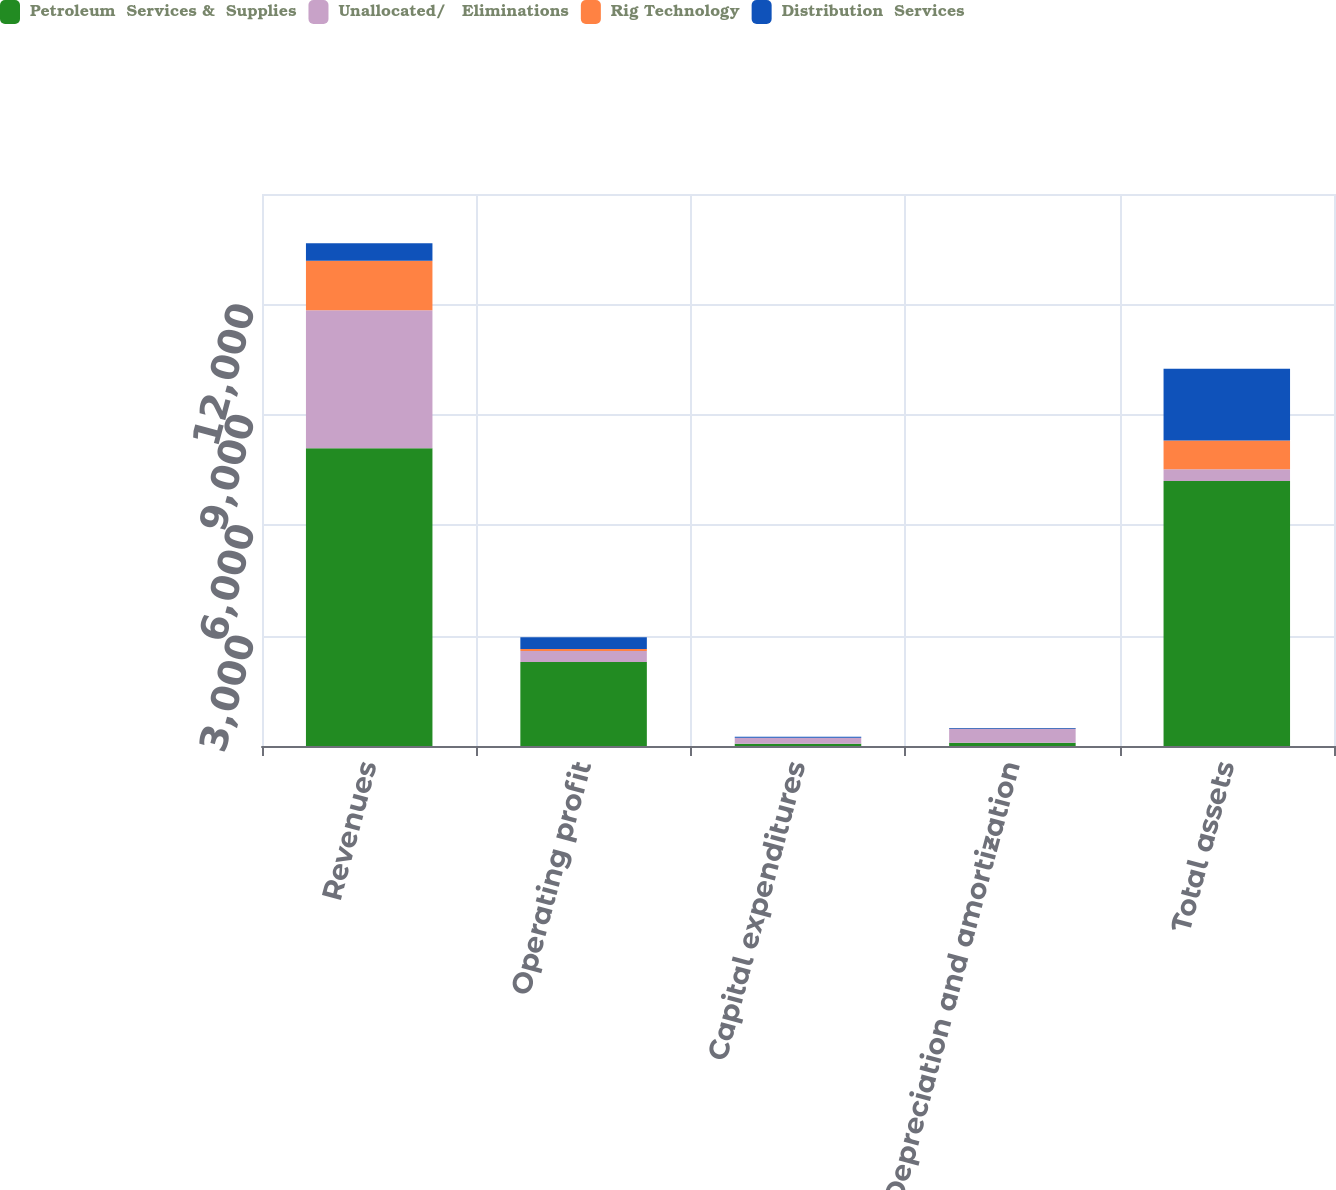<chart> <loc_0><loc_0><loc_500><loc_500><stacked_bar_chart><ecel><fcel>Revenues<fcel>Operating profit<fcel>Capital expenditures<fcel>Depreciation and amortization<fcel>Total assets<nl><fcel>Petroleum  Services &  Supplies<fcel>8093<fcel>2283<fcel>61<fcel>90<fcel>7203<nl><fcel>Unallocated/   Eliminations<fcel>3745<fcel>301<fcel>161<fcel>374<fcel>319<nl><fcel>Rig Technology<fcel>1350<fcel>50<fcel>3<fcel>8<fcel>781<nl><fcel>Distribution  Services<fcel>476<fcel>319<fcel>25<fcel>18<fcel>1947<nl></chart> 